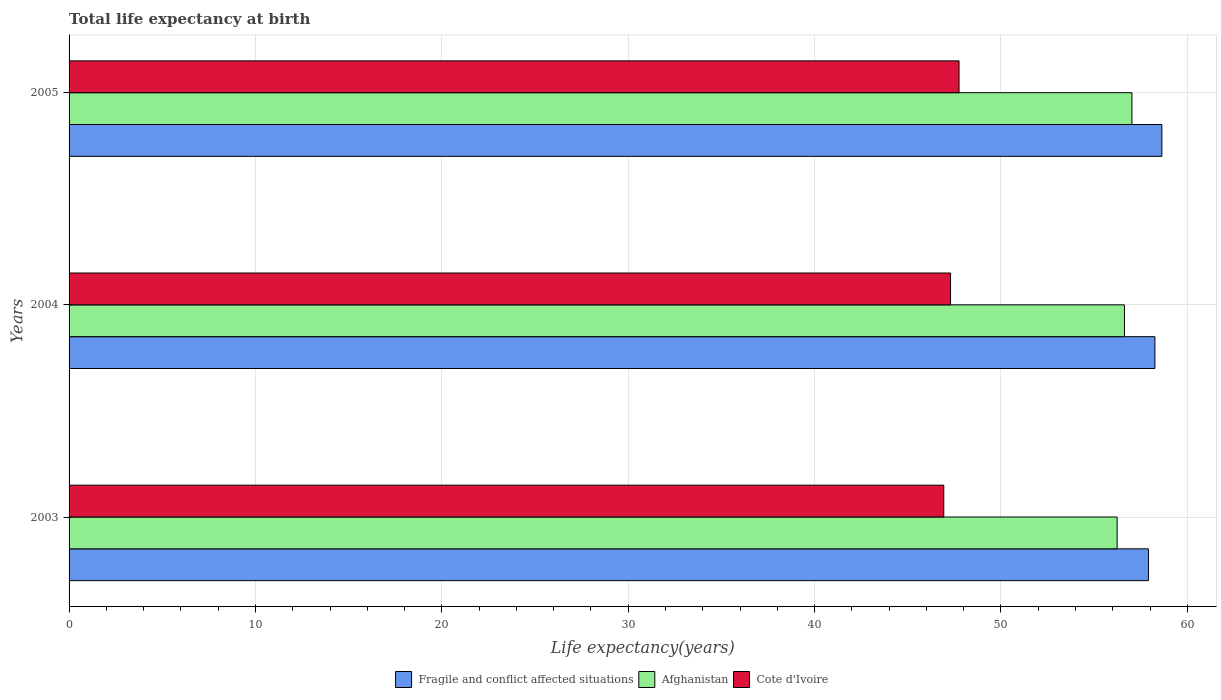How many different coloured bars are there?
Provide a succinct answer. 3. How many groups of bars are there?
Offer a very short reply. 3. Are the number of bars on each tick of the Y-axis equal?
Keep it short and to the point. Yes. How many bars are there on the 3rd tick from the bottom?
Your answer should be very brief. 3. What is the label of the 2nd group of bars from the top?
Make the answer very short. 2004. What is the life expectancy at birth in in Afghanistan in 2003?
Give a very brief answer. 56.24. Across all years, what is the maximum life expectancy at birth in in Fragile and conflict affected situations?
Provide a short and direct response. 58.63. Across all years, what is the minimum life expectancy at birth in in Fragile and conflict affected situations?
Your answer should be compact. 57.92. In which year was the life expectancy at birth in in Cote d'Ivoire minimum?
Your answer should be compact. 2003. What is the total life expectancy at birth in in Cote d'Ivoire in the graph?
Offer a terse response. 141.98. What is the difference between the life expectancy at birth in in Fragile and conflict affected situations in 2003 and that in 2005?
Your answer should be compact. -0.72. What is the difference between the life expectancy at birth in in Afghanistan in 2005 and the life expectancy at birth in in Cote d'Ivoire in 2003?
Give a very brief answer. 10.09. What is the average life expectancy at birth in in Cote d'Ivoire per year?
Ensure brevity in your answer.  47.33. In the year 2003, what is the difference between the life expectancy at birth in in Fragile and conflict affected situations and life expectancy at birth in in Afghanistan?
Make the answer very short. 1.68. In how many years, is the life expectancy at birth in in Afghanistan greater than 46 years?
Make the answer very short. 3. What is the ratio of the life expectancy at birth in in Cote d'Ivoire in 2004 to that in 2005?
Your answer should be compact. 0.99. Is the difference between the life expectancy at birth in in Fragile and conflict affected situations in 2004 and 2005 greater than the difference between the life expectancy at birth in in Afghanistan in 2004 and 2005?
Provide a short and direct response. Yes. What is the difference between the highest and the second highest life expectancy at birth in in Cote d'Ivoire?
Provide a succinct answer. 0.46. What is the difference between the highest and the lowest life expectancy at birth in in Cote d'Ivoire?
Make the answer very short. 0.82. In how many years, is the life expectancy at birth in in Cote d'Ivoire greater than the average life expectancy at birth in in Cote d'Ivoire taken over all years?
Your answer should be very brief. 1. Is the sum of the life expectancy at birth in in Afghanistan in 2004 and 2005 greater than the maximum life expectancy at birth in in Fragile and conflict affected situations across all years?
Provide a succinct answer. Yes. What does the 1st bar from the top in 2005 represents?
Keep it short and to the point. Cote d'Ivoire. What does the 1st bar from the bottom in 2005 represents?
Provide a short and direct response. Fragile and conflict affected situations. Is it the case that in every year, the sum of the life expectancy at birth in in Fragile and conflict affected situations and life expectancy at birth in in Cote d'Ivoire is greater than the life expectancy at birth in in Afghanistan?
Ensure brevity in your answer.  Yes. Are all the bars in the graph horizontal?
Give a very brief answer. Yes. How many years are there in the graph?
Offer a terse response. 3. Are the values on the major ticks of X-axis written in scientific E-notation?
Your answer should be very brief. No. Does the graph contain any zero values?
Offer a terse response. No. Where does the legend appear in the graph?
Your answer should be compact. Bottom center. How many legend labels are there?
Ensure brevity in your answer.  3. What is the title of the graph?
Offer a terse response. Total life expectancy at birth. Does "Croatia" appear as one of the legend labels in the graph?
Your answer should be compact. No. What is the label or title of the X-axis?
Your answer should be very brief. Life expectancy(years). What is the Life expectancy(years) in Fragile and conflict affected situations in 2003?
Your answer should be very brief. 57.92. What is the Life expectancy(years) in Afghanistan in 2003?
Your response must be concise. 56.24. What is the Life expectancy(years) in Cote d'Ivoire in 2003?
Your answer should be compact. 46.93. What is the Life expectancy(years) of Fragile and conflict affected situations in 2004?
Your response must be concise. 58.26. What is the Life expectancy(years) in Afghanistan in 2004?
Ensure brevity in your answer.  56.63. What is the Life expectancy(years) of Cote d'Ivoire in 2004?
Provide a short and direct response. 47.3. What is the Life expectancy(years) of Fragile and conflict affected situations in 2005?
Provide a succinct answer. 58.63. What is the Life expectancy(years) of Afghanistan in 2005?
Make the answer very short. 57.03. What is the Life expectancy(years) in Cote d'Ivoire in 2005?
Provide a succinct answer. 47.75. Across all years, what is the maximum Life expectancy(years) in Fragile and conflict affected situations?
Provide a short and direct response. 58.63. Across all years, what is the maximum Life expectancy(years) in Afghanistan?
Your response must be concise. 57.03. Across all years, what is the maximum Life expectancy(years) in Cote d'Ivoire?
Give a very brief answer. 47.75. Across all years, what is the minimum Life expectancy(years) in Fragile and conflict affected situations?
Your response must be concise. 57.92. Across all years, what is the minimum Life expectancy(years) of Afghanistan?
Your answer should be compact. 56.24. Across all years, what is the minimum Life expectancy(years) in Cote d'Ivoire?
Give a very brief answer. 46.93. What is the total Life expectancy(years) of Fragile and conflict affected situations in the graph?
Make the answer very short. 174.81. What is the total Life expectancy(years) in Afghanistan in the graph?
Offer a terse response. 169.89. What is the total Life expectancy(years) in Cote d'Ivoire in the graph?
Offer a terse response. 141.98. What is the difference between the Life expectancy(years) of Fragile and conflict affected situations in 2003 and that in 2004?
Ensure brevity in your answer.  -0.35. What is the difference between the Life expectancy(years) of Afghanistan in 2003 and that in 2004?
Offer a very short reply. -0.39. What is the difference between the Life expectancy(years) of Cote d'Ivoire in 2003 and that in 2004?
Provide a short and direct response. -0.36. What is the difference between the Life expectancy(years) in Fragile and conflict affected situations in 2003 and that in 2005?
Your response must be concise. -0.72. What is the difference between the Life expectancy(years) in Afghanistan in 2003 and that in 2005?
Keep it short and to the point. -0.79. What is the difference between the Life expectancy(years) of Cote d'Ivoire in 2003 and that in 2005?
Make the answer very short. -0.82. What is the difference between the Life expectancy(years) of Fragile and conflict affected situations in 2004 and that in 2005?
Keep it short and to the point. -0.37. What is the difference between the Life expectancy(years) of Afghanistan in 2004 and that in 2005?
Your response must be concise. -0.4. What is the difference between the Life expectancy(years) of Cote d'Ivoire in 2004 and that in 2005?
Your response must be concise. -0.46. What is the difference between the Life expectancy(years) in Fragile and conflict affected situations in 2003 and the Life expectancy(years) in Afghanistan in 2004?
Your answer should be very brief. 1.29. What is the difference between the Life expectancy(years) in Fragile and conflict affected situations in 2003 and the Life expectancy(years) in Cote d'Ivoire in 2004?
Provide a succinct answer. 10.62. What is the difference between the Life expectancy(years) of Afghanistan in 2003 and the Life expectancy(years) of Cote d'Ivoire in 2004?
Provide a short and direct response. 8.94. What is the difference between the Life expectancy(years) of Fragile and conflict affected situations in 2003 and the Life expectancy(years) of Afghanistan in 2005?
Your response must be concise. 0.89. What is the difference between the Life expectancy(years) of Fragile and conflict affected situations in 2003 and the Life expectancy(years) of Cote d'Ivoire in 2005?
Keep it short and to the point. 10.16. What is the difference between the Life expectancy(years) in Afghanistan in 2003 and the Life expectancy(years) in Cote d'Ivoire in 2005?
Give a very brief answer. 8.48. What is the difference between the Life expectancy(years) in Fragile and conflict affected situations in 2004 and the Life expectancy(years) in Afghanistan in 2005?
Your response must be concise. 1.24. What is the difference between the Life expectancy(years) of Fragile and conflict affected situations in 2004 and the Life expectancy(years) of Cote d'Ivoire in 2005?
Your answer should be very brief. 10.51. What is the difference between the Life expectancy(years) of Afghanistan in 2004 and the Life expectancy(years) of Cote d'Ivoire in 2005?
Provide a short and direct response. 8.87. What is the average Life expectancy(years) of Fragile and conflict affected situations per year?
Keep it short and to the point. 58.27. What is the average Life expectancy(years) of Afghanistan per year?
Your answer should be compact. 56.63. What is the average Life expectancy(years) in Cote d'Ivoire per year?
Provide a short and direct response. 47.33. In the year 2003, what is the difference between the Life expectancy(years) in Fragile and conflict affected situations and Life expectancy(years) in Afghanistan?
Your answer should be compact. 1.68. In the year 2003, what is the difference between the Life expectancy(years) in Fragile and conflict affected situations and Life expectancy(years) in Cote d'Ivoire?
Your answer should be compact. 10.98. In the year 2003, what is the difference between the Life expectancy(years) in Afghanistan and Life expectancy(years) in Cote d'Ivoire?
Make the answer very short. 9.3. In the year 2004, what is the difference between the Life expectancy(years) of Fragile and conflict affected situations and Life expectancy(years) of Afghanistan?
Provide a short and direct response. 1.64. In the year 2004, what is the difference between the Life expectancy(years) of Fragile and conflict affected situations and Life expectancy(years) of Cote d'Ivoire?
Your answer should be very brief. 10.97. In the year 2004, what is the difference between the Life expectancy(years) of Afghanistan and Life expectancy(years) of Cote d'Ivoire?
Provide a short and direct response. 9.33. In the year 2005, what is the difference between the Life expectancy(years) of Fragile and conflict affected situations and Life expectancy(years) of Afghanistan?
Make the answer very short. 1.61. In the year 2005, what is the difference between the Life expectancy(years) of Fragile and conflict affected situations and Life expectancy(years) of Cote d'Ivoire?
Give a very brief answer. 10.88. In the year 2005, what is the difference between the Life expectancy(years) in Afghanistan and Life expectancy(years) in Cote d'Ivoire?
Your answer should be compact. 9.28. What is the ratio of the Life expectancy(years) of Afghanistan in 2003 to that in 2004?
Ensure brevity in your answer.  0.99. What is the ratio of the Life expectancy(years) in Cote d'Ivoire in 2003 to that in 2004?
Your response must be concise. 0.99. What is the ratio of the Life expectancy(years) in Fragile and conflict affected situations in 2003 to that in 2005?
Offer a terse response. 0.99. What is the ratio of the Life expectancy(years) of Afghanistan in 2003 to that in 2005?
Give a very brief answer. 0.99. What is the ratio of the Life expectancy(years) of Cote d'Ivoire in 2003 to that in 2005?
Keep it short and to the point. 0.98. What is the ratio of the Life expectancy(years) in Afghanistan in 2004 to that in 2005?
Keep it short and to the point. 0.99. What is the difference between the highest and the second highest Life expectancy(years) of Fragile and conflict affected situations?
Give a very brief answer. 0.37. What is the difference between the highest and the second highest Life expectancy(years) in Afghanistan?
Your response must be concise. 0.4. What is the difference between the highest and the second highest Life expectancy(years) of Cote d'Ivoire?
Provide a succinct answer. 0.46. What is the difference between the highest and the lowest Life expectancy(years) in Fragile and conflict affected situations?
Give a very brief answer. 0.72. What is the difference between the highest and the lowest Life expectancy(years) of Afghanistan?
Offer a terse response. 0.79. What is the difference between the highest and the lowest Life expectancy(years) in Cote d'Ivoire?
Provide a short and direct response. 0.82. 